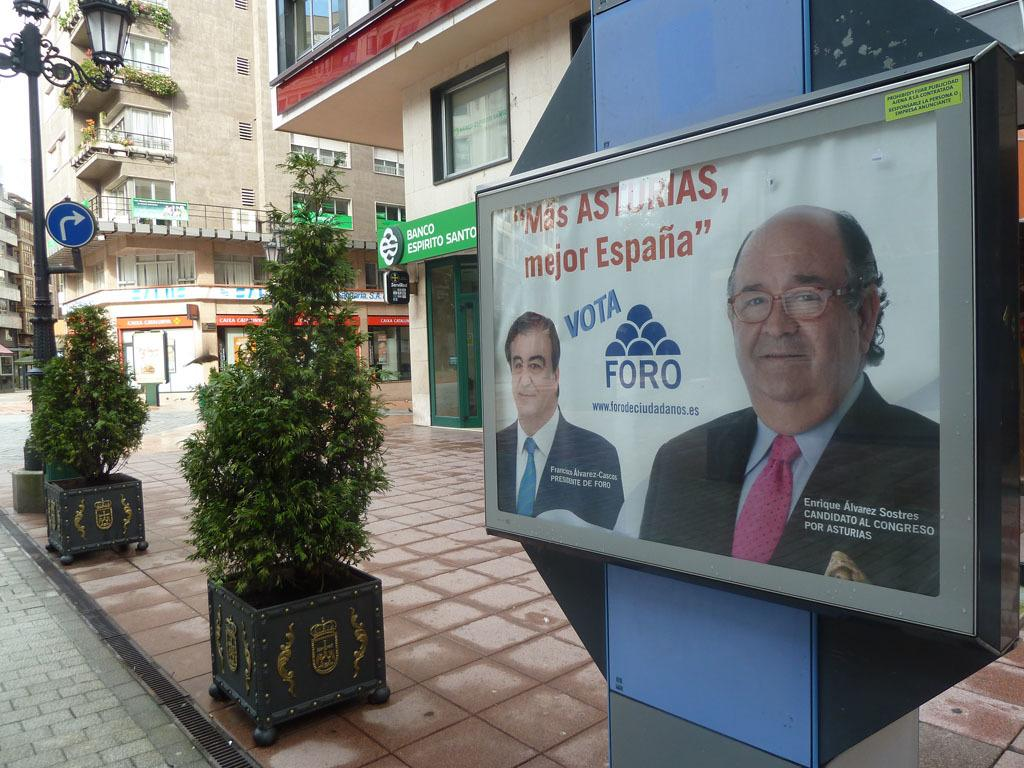What type of structures can be seen in the image? There are buildings in the image. What architectural features are present on the buildings? There are windows visible on the buildings. What is the purpose of the light pole in the image? The light pole provides illumination in the area. What is the sign board used for in the image? The sign board displays information or advertisements. What type of vegetation is present in the image? There are plants in the image. What type of boards are present in the image, and what do they contain? There are boards with text and images in the image. What can be seen in the sky in the image? The sky is visible in the image. How many snails can be seen crawling on the light pole in the image? There are no snails present on the light pole in the image. What type of flowers are planted near the sign board in the image? There are no flowers mentioned or visible in the image. 